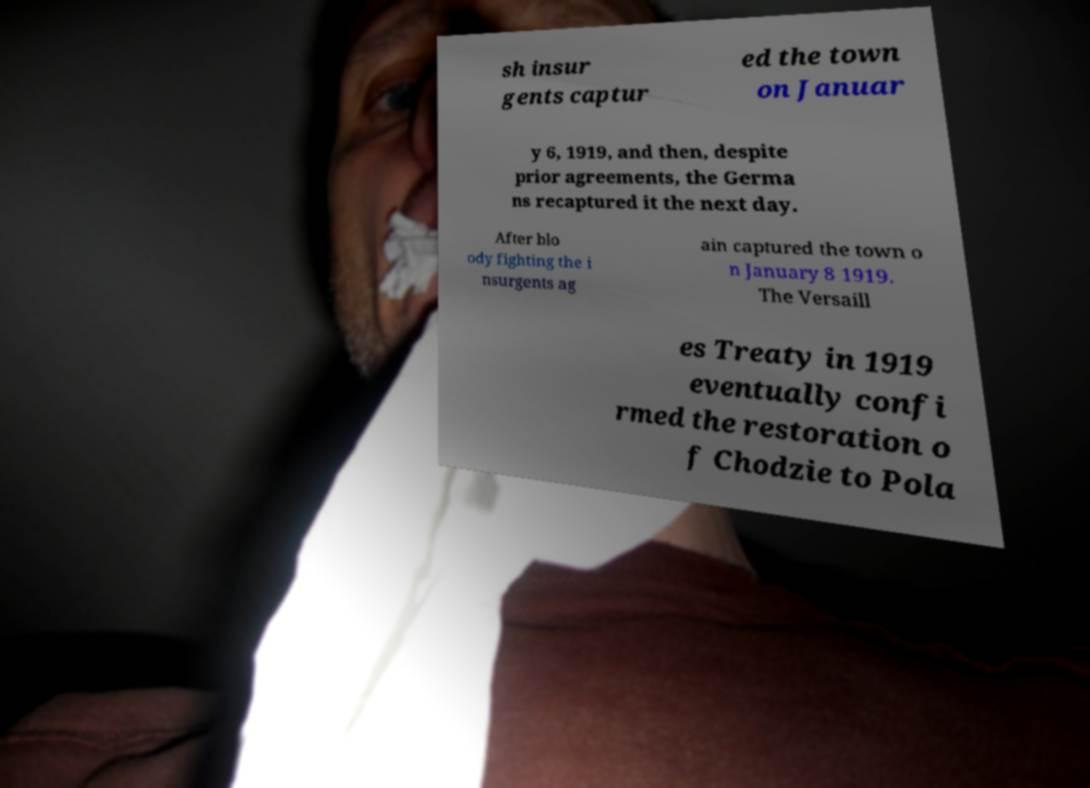Please identify and transcribe the text found in this image. sh insur gents captur ed the town on Januar y 6, 1919, and then, despite prior agreements, the Germa ns recaptured it the next day. After blo ody fighting the i nsurgents ag ain captured the town o n January 8 1919. The Versaill es Treaty in 1919 eventually confi rmed the restoration o f Chodzie to Pola 